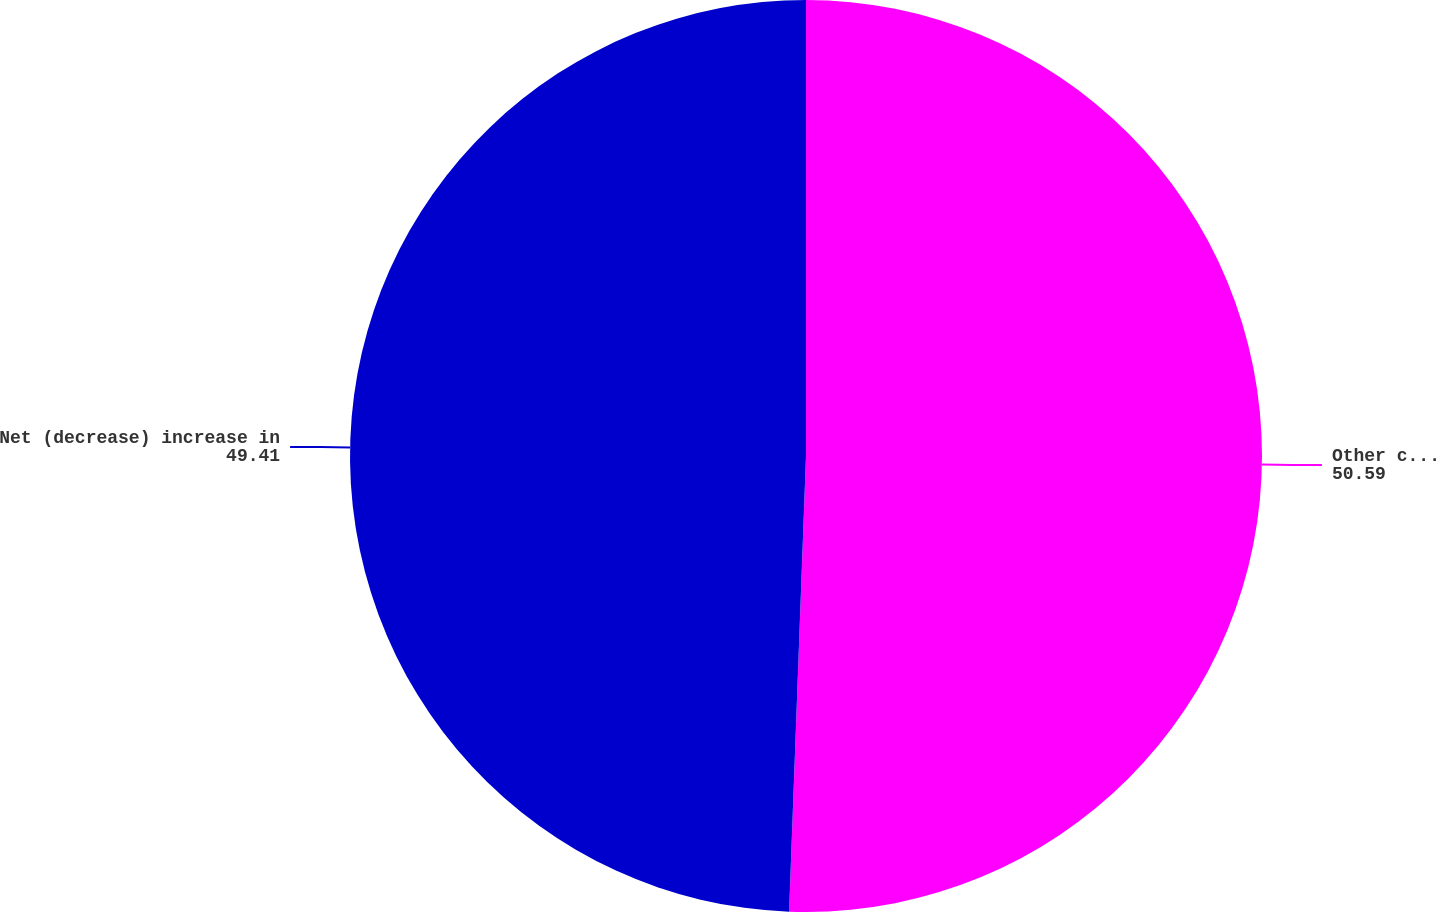Convert chart to OTSL. <chart><loc_0><loc_0><loc_500><loc_500><pie_chart><fcel>Other comprehensive (loss)<fcel>Net (decrease) increase in<nl><fcel>50.59%<fcel>49.41%<nl></chart> 